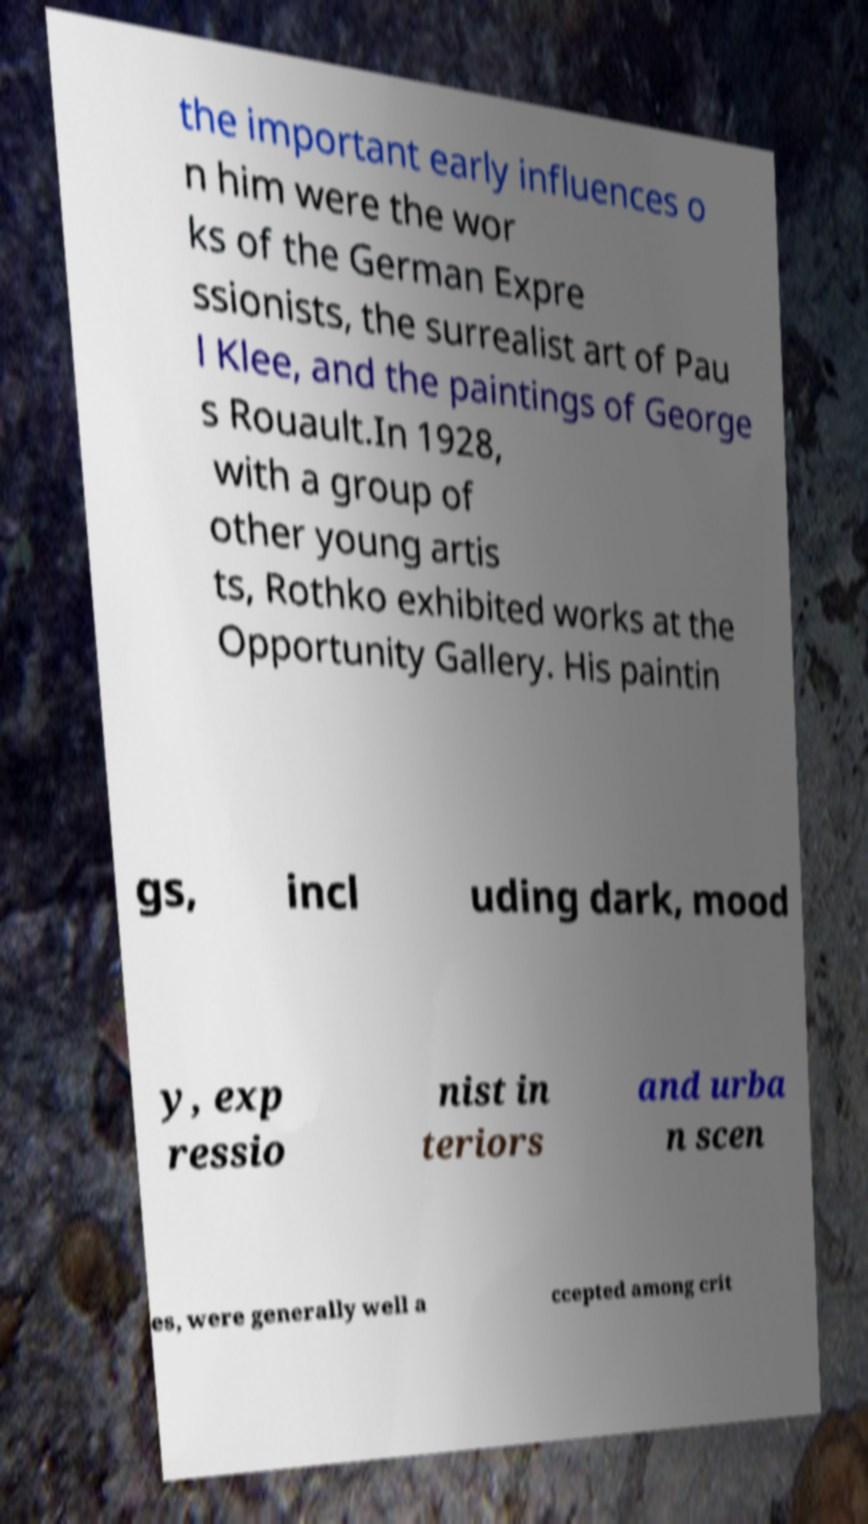Please read and relay the text visible in this image. What does it say? the important early influences o n him were the wor ks of the German Expre ssionists, the surrealist art of Pau l Klee, and the paintings of George s Rouault.In 1928, with a group of other young artis ts, Rothko exhibited works at the Opportunity Gallery. His paintin gs, incl uding dark, mood y, exp ressio nist in teriors and urba n scen es, were generally well a ccepted among crit 